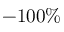<formula> <loc_0><loc_0><loc_500><loc_500>- 1 0 0 \%</formula> 